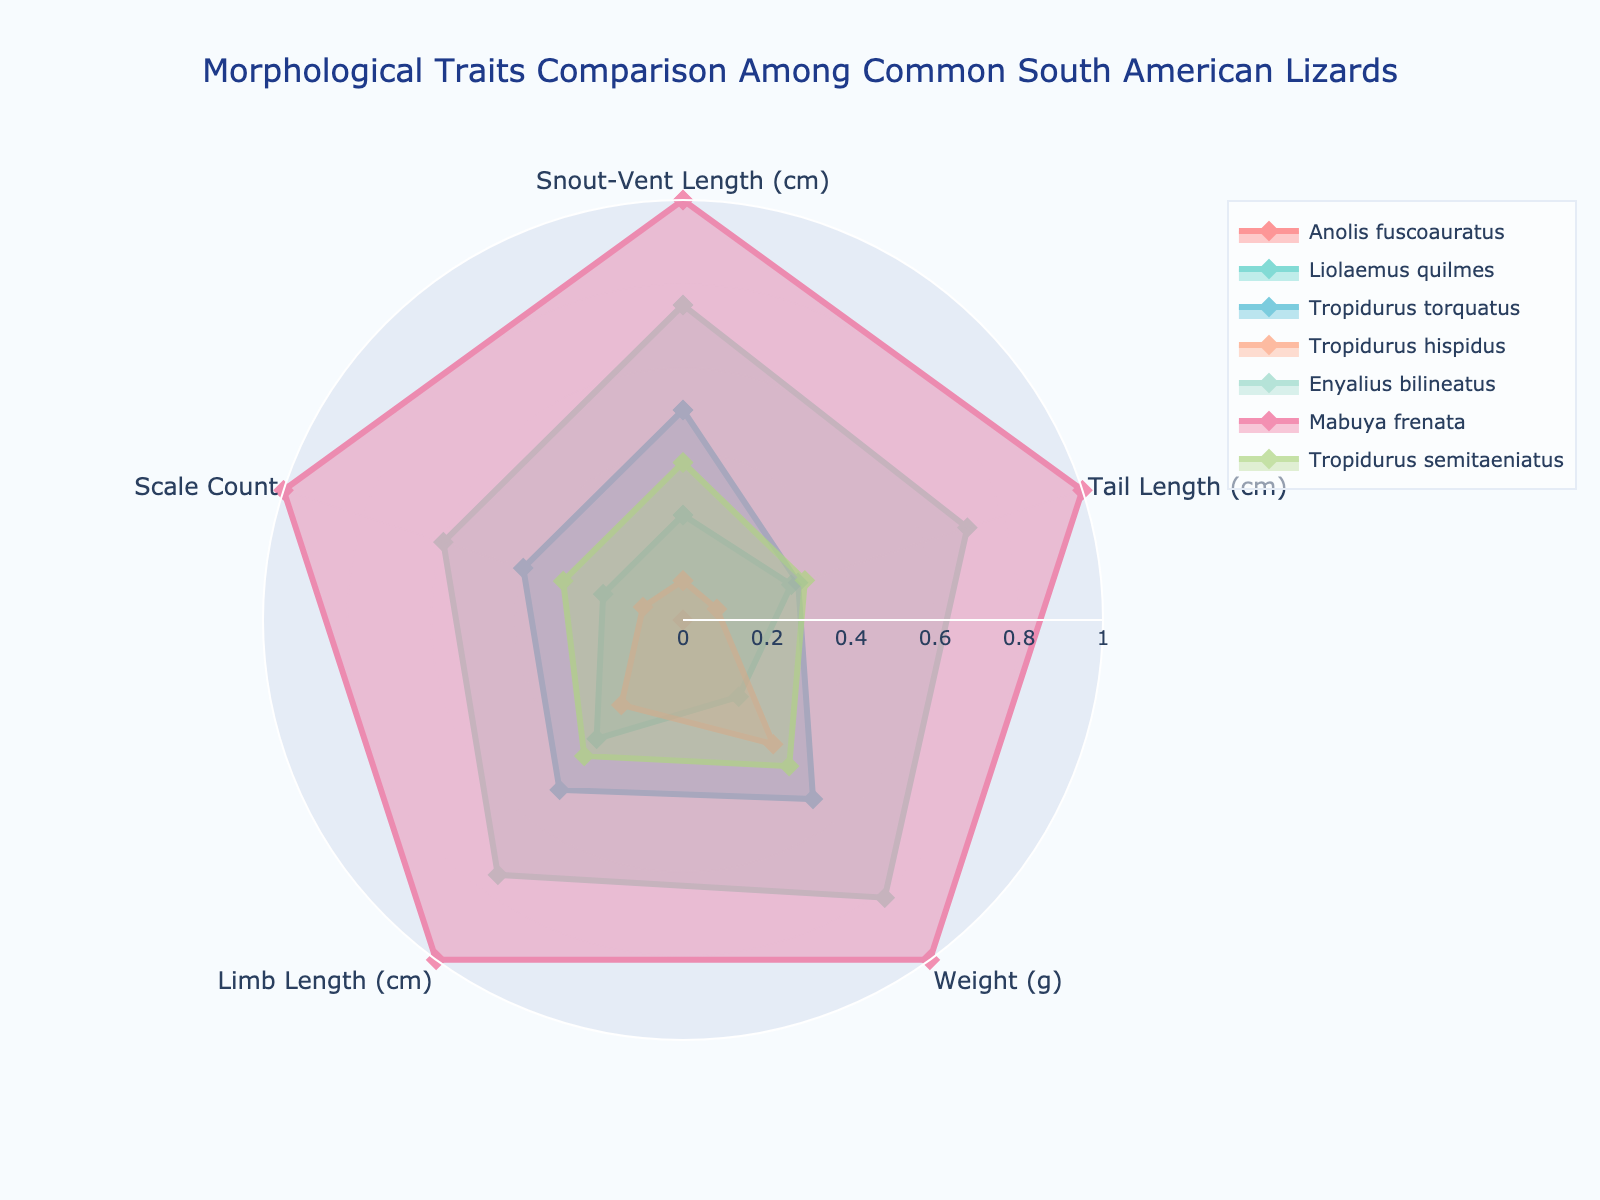How many lizard species are compared in the radar chart? By counting the number of different names in the legend, we can determine the number of species visualized.
Answer: 7 Which lizard species has the largest Snout-Vent Length (cm)? By visually scanning the radar chart for the category 'Snout-Vent Length (cm)', we can find the species with the highest value in this parameter.
Answer: Mabuya frenata What is the average Tail Length (cm) of Tropidurus hispidus and Tropidurus torquatus compared to the other species? First, identify the 'Tail Length (cm)' values for Tropidurus hispidus and Tropidurus torquatus. Then, compare the average of these two values with the other species by visual reference.
Answer: Slightly lower Which species has the most uniform distribution across all morphological traits? Examine all the radar plots and identify the species whose values are evenly spread and less extreme across all categories compared to others.
Answer: Tropidurus semitaeniatus Which lizard has the highest Weight (g)? By looking at the category 'Weight (g)' and finding the outermost point on the axis, the species with the maximum value can be identified.
Answer: Mabuya frenata How do the Scale Counts of Anolis fuscoauratus compare to Enyalius bilineatus? Identify the 'Scale Count' values for both species and compare their positions on the radar chart.
Answer: Enyalius bilineatus has higher Scale Count than Anolis fuscoauratus Do any two species have identical values for Limb Length (cm)? Scan the 'Limb Length (cm)' axis and check if any two lines overlap exactly on this axis.
Answer: No Which species stands out in terms of Tail Length (cm)? Observe the Tail Length (cm) axis to see which species projects out the furthest from the center.
Answer: Mabuya frenata What is the normalized value range for Weight (g) on the radar chart? The radar chart uses values normalized between 0 and 1, hence the range for all parameters, including Weight (g), follows this normalization.
Answer: 0 to 1 Which trait shows the most variation among all species? Look for the category with the widest spread of data points on the radar chart to determine which trait varies the most among species.
Answer: Weight (g) 